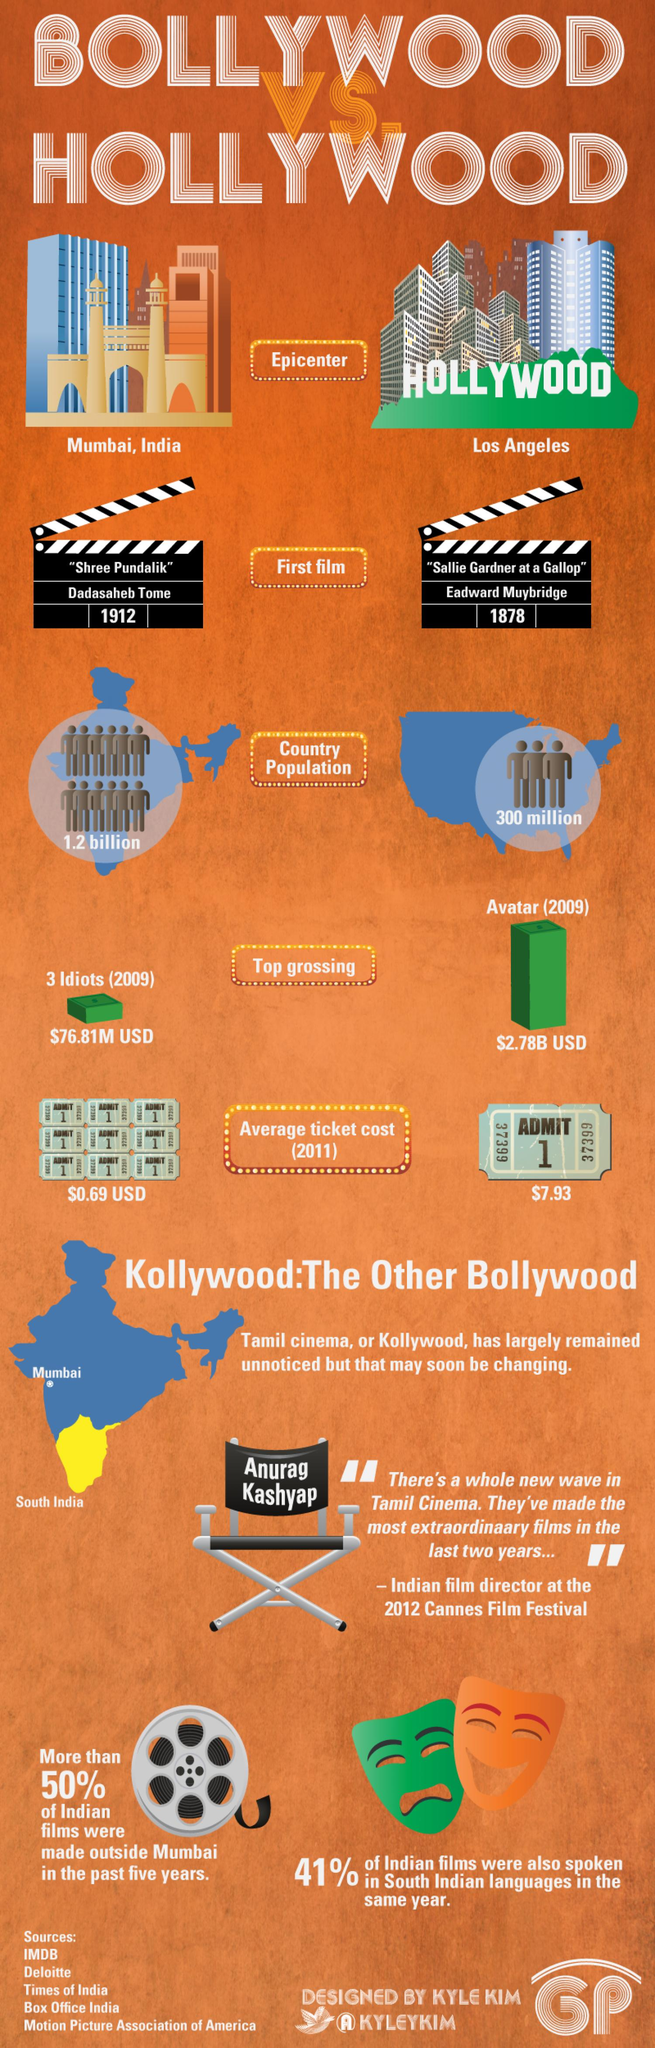Give some essential details in this illustration. Los Angeles is known as the epicenter of Hollywood. The population of India is approximately 1.2 billion. The first movie of Hollywood was released in 1878. The average ticket cost of a Hollywood movie in 2011 was approximately $7.93. It is widely acknowledged that "Avatar" was the highest grossing movie in Hollywood. 